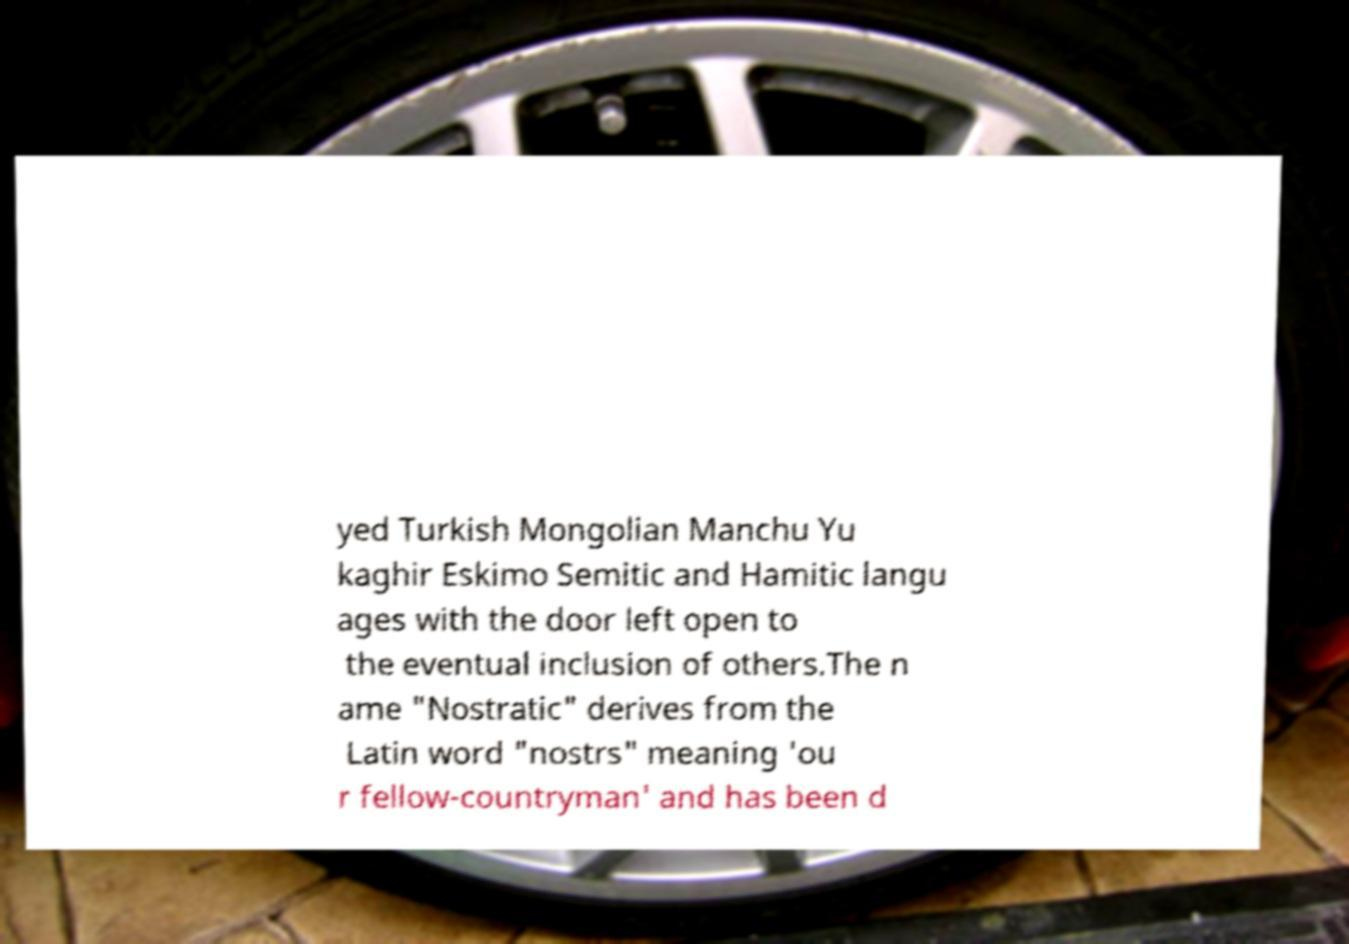Can you read and provide the text displayed in the image?This photo seems to have some interesting text. Can you extract and type it out for me? yed Turkish Mongolian Manchu Yu kaghir Eskimo Semitic and Hamitic langu ages with the door left open to the eventual inclusion of others.The n ame "Nostratic" derives from the Latin word "nostrs" meaning 'ou r fellow-countryman' and has been d 